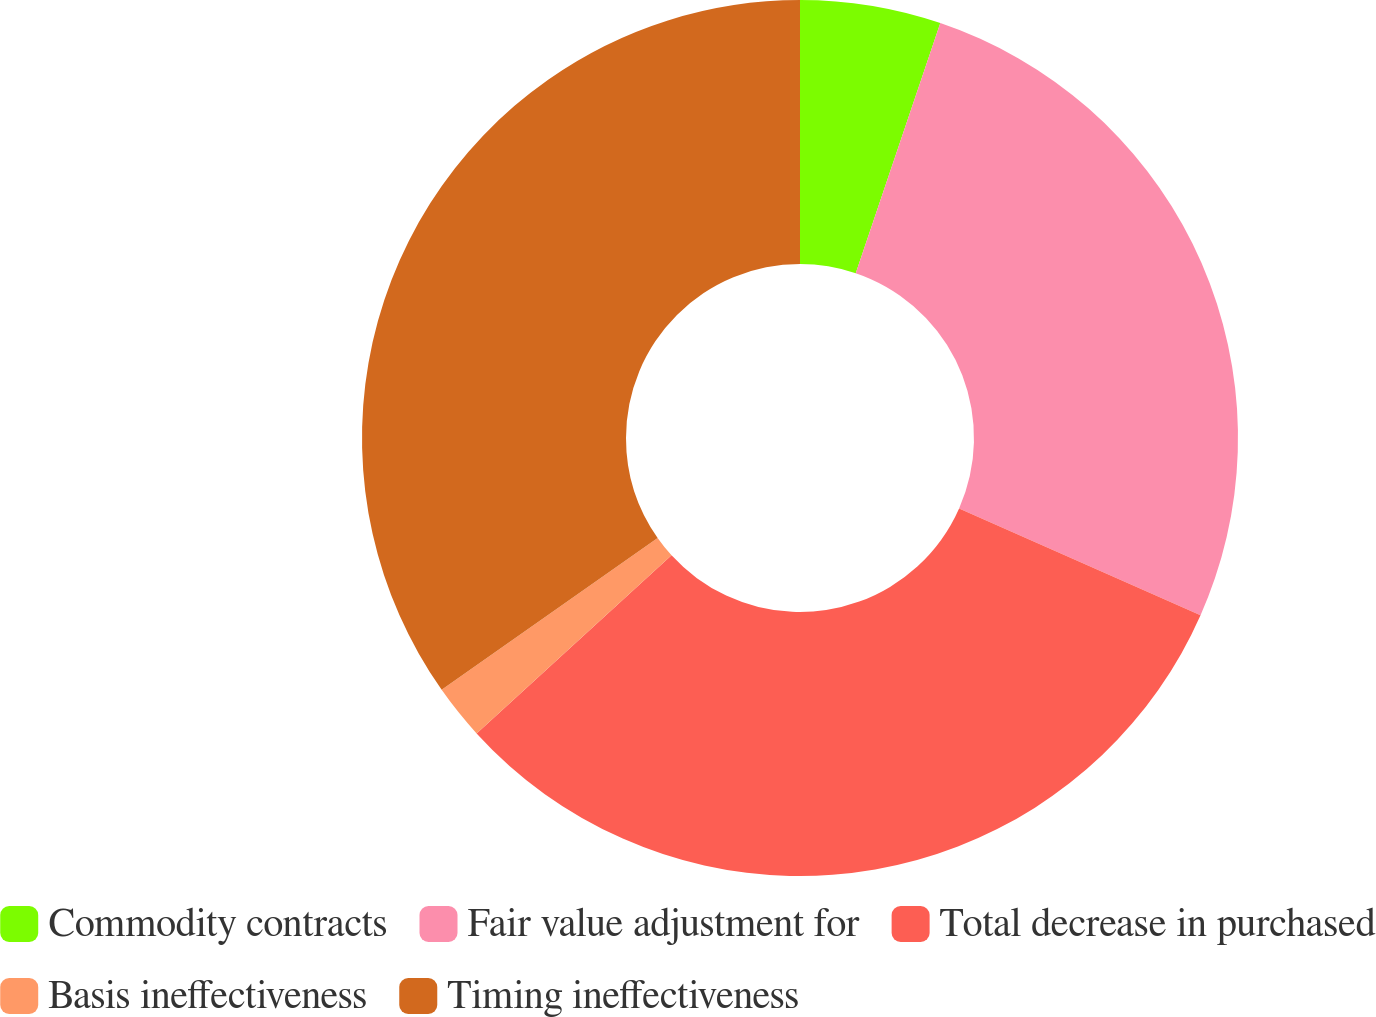Convert chart to OTSL. <chart><loc_0><loc_0><loc_500><loc_500><pie_chart><fcel>Commodity contracts<fcel>Fair value adjustment for<fcel>Total decrease in purchased<fcel>Basis ineffectiveness<fcel>Timing ineffectiveness<nl><fcel>5.19%<fcel>26.44%<fcel>31.59%<fcel>2.03%<fcel>34.75%<nl></chart> 